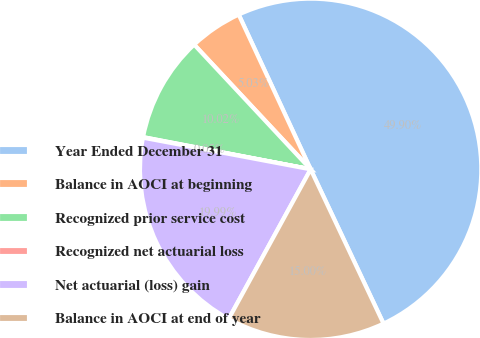Convert chart. <chart><loc_0><loc_0><loc_500><loc_500><pie_chart><fcel>Year Ended December 31<fcel>Balance in AOCI at beginning<fcel>Recognized prior service cost<fcel>Recognized net actuarial loss<fcel>Net actuarial (loss) gain<fcel>Balance in AOCI at end of year<nl><fcel>49.9%<fcel>5.03%<fcel>10.02%<fcel>0.05%<fcel>19.99%<fcel>15.0%<nl></chart> 